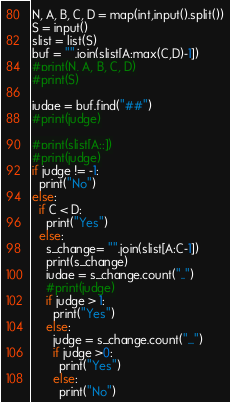Convert code to text. <code><loc_0><loc_0><loc_500><loc_500><_Python_>N, A, B, C, D = map(int,input().split())
S = input()
slist = list(S)
buf = "".join(slist[A:max(C,D)-1])
#print(N, A, B, C, D)
#print(S)

judge = buf.find("##")
#print(judge)

#print(slist[A::])
#print(judge)
if judge != -1:
  print("No")
else:
  if C < D:
    print("Yes")
  else:
    s_change= "".join(slist[A:C-1])
    print(s_change)
    judge = s_change.count("..")
    #print(judge)
    if judge > 1:
      print("Yes")
    else:
      judge = s_change.count("...")
      if judge >0:
        print("Yes")
      else:
        print("No")</code> 